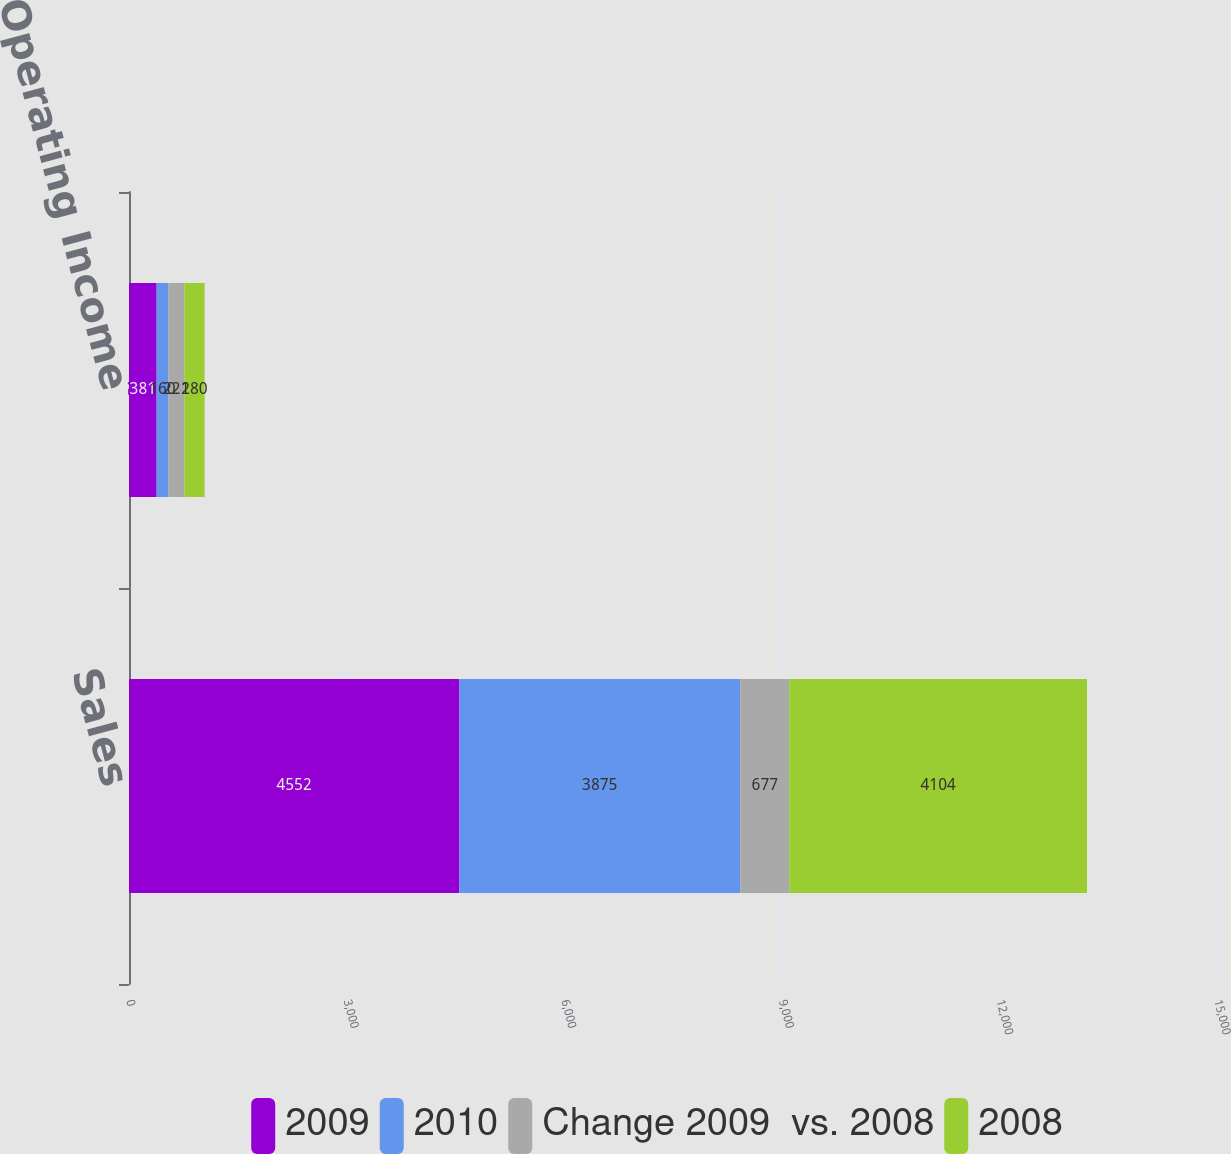Convert chart. <chart><loc_0><loc_0><loc_500><loc_500><stacked_bar_chart><ecel><fcel>Sales<fcel>Operating Income<nl><fcel>2009<fcel>4552<fcel>381<nl><fcel>2010<fcel>3875<fcel>160<nl><fcel>Change 2009  vs. 2008<fcel>677<fcel>221<nl><fcel>2008<fcel>4104<fcel>280<nl></chart> 